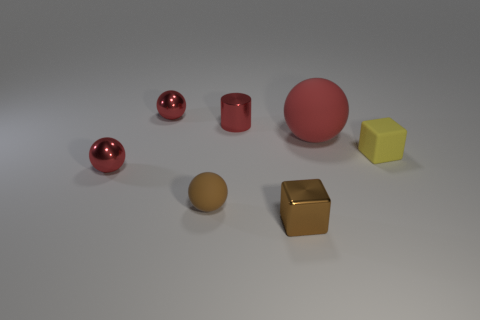Do the big matte object and the yellow matte thing have the same shape?
Make the answer very short. No. Is there a brown metal object of the same shape as the large red rubber thing?
Make the answer very short. No. There is a yellow matte thing that is the same size as the cylinder; what is its shape?
Your answer should be compact. Cube. The small red sphere in front of the shiny sphere that is on the right side of the red shiny ball that is in front of the yellow thing is made of what material?
Give a very brief answer. Metal. Does the red rubber ball have the same size as the yellow block?
Provide a short and direct response. No. What material is the small yellow thing?
Give a very brief answer. Rubber. What material is the object that is the same color as the metal cube?
Your response must be concise. Rubber. Do the red matte object on the right side of the small brown matte thing and the brown shiny object have the same shape?
Offer a terse response. No. How many objects are brown matte spheres or small shiny cubes?
Provide a succinct answer. 2. Do the tiny cube that is behind the brown shiny block and the large red sphere have the same material?
Your response must be concise. Yes. 